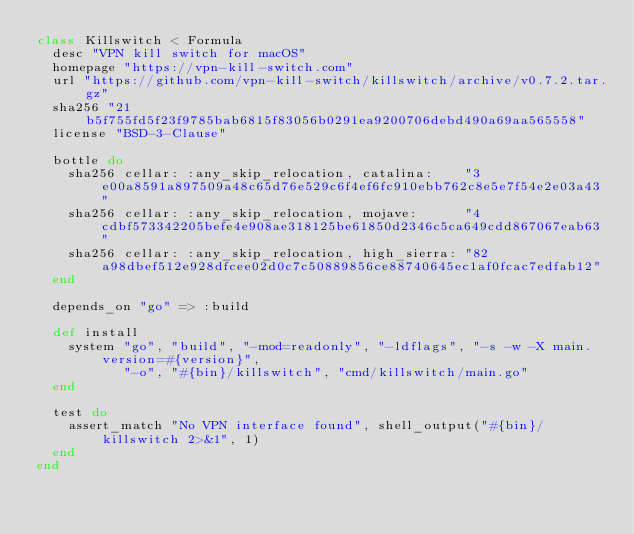Convert code to text. <code><loc_0><loc_0><loc_500><loc_500><_Ruby_>class Killswitch < Formula
  desc "VPN kill switch for macOS"
  homepage "https://vpn-kill-switch.com"
  url "https://github.com/vpn-kill-switch/killswitch/archive/v0.7.2.tar.gz"
  sha256 "21b5f755fd5f23f9785bab6815f83056b0291ea9200706debd490a69aa565558"
  license "BSD-3-Clause"

  bottle do
    sha256 cellar: :any_skip_relocation, catalina:    "3e00a8591a897509a48c65d76e529c6f4ef6fc910ebb762c8e5e7f54e2e03a43"
    sha256 cellar: :any_skip_relocation, mojave:      "4cdbf573342205befe4e908ae318125be61850d2346c5ca649cdd867067eab63"
    sha256 cellar: :any_skip_relocation, high_sierra: "82a98dbef512e928dfcee02d0c7c50889856ce88740645ec1af0fcac7edfab12"
  end

  depends_on "go" => :build

  def install
    system "go", "build", "-mod=readonly", "-ldflags", "-s -w -X main.version=#{version}",
           "-o", "#{bin}/killswitch", "cmd/killswitch/main.go"
  end

  test do
    assert_match "No VPN interface found", shell_output("#{bin}/killswitch 2>&1", 1)
  end
end
</code> 